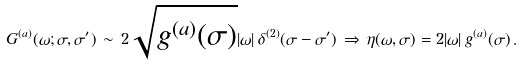Convert formula to latex. <formula><loc_0><loc_0><loc_500><loc_500>G ^ { ( a ) } ( \omega ; \sigma , \sigma ^ { \prime } ) \, \sim \, 2 \sqrt { g ^ { ( a ) } ( \sigma ) } | \omega | \, \delta ^ { ( 2 ) } ( \sigma - \sigma ^ { \prime } ) \, \Rightarrow \, \eta ( \omega , \sigma ) = 2 | \omega | \, g ^ { ( a ) } ( \sigma ) \, .</formula> 